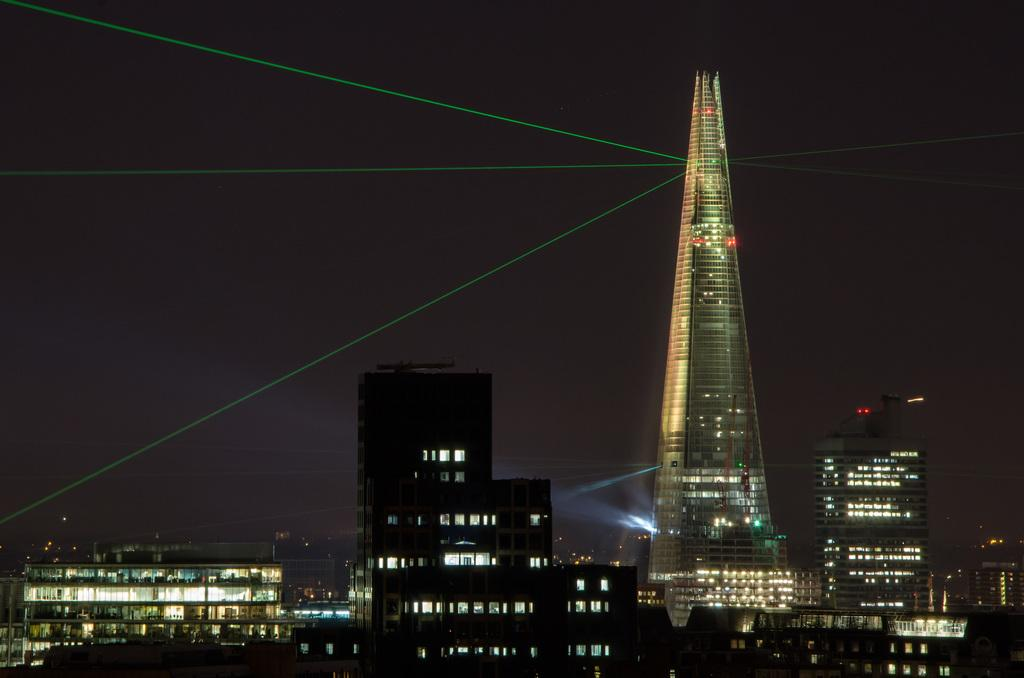What type of structures are present in the image? There are buildings in the image. What feature can be seen in the buildings? There are lights in the buildings. What can be observed in the image due to the presence of lights? Light rays are visible in the image. What can be inferred about the time of day or lighting conditions when the image was taken? The image was taken in the dark. What type of insect can be seen repairing the buildings in the image? There is no insect present in the image, and no repair work is being done on the buildings. 